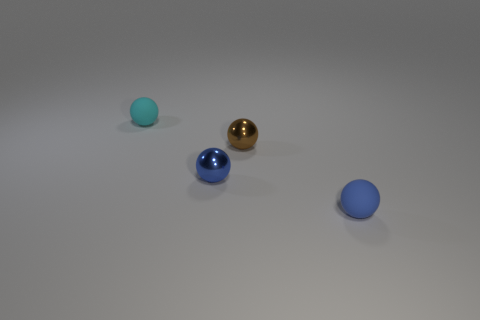There is a tiny thing behind the brown metallic thing; what is it made of?
Your response must be concise. Rubber. How many big objects are brown things or cyan matte spheres?
Offer a very short reply. 0. There is a tiny sphere that is right of the small brown sphere; is there a tiny cyan rubber thing that is to the left of it?
Offer a very short reply. Yes. Is the number of small blue matte spheres that are left of the tiny cyan rubber ball less than the number of tiny objects?
Provide a short and direct response. Yes. Do the small blue sphere that is left of the small blue rubber thing and the tiny brown thing have the same material?
Your answer should be very brief. Yes. Are there fewer small objects that are behind the tiny blue metal object than small spheres that are in front of the tiny cyan sphere?
Make the answer very short. Yes. Does the rubber thing to the right of the cyan rubber ball have the same color as the metal object in front of the tiny brown shiny ball?
Your response must be concise. Yes. Is there a blue sphere that has the same material as the small cyan thing?
Your response must be concise. Yes. Is the number of small blue cubes greater than the number of brown things?
Your answer should be compact. No. Is the brown thing the same shape as the cyan object?
Make the answer very short. Yes. 